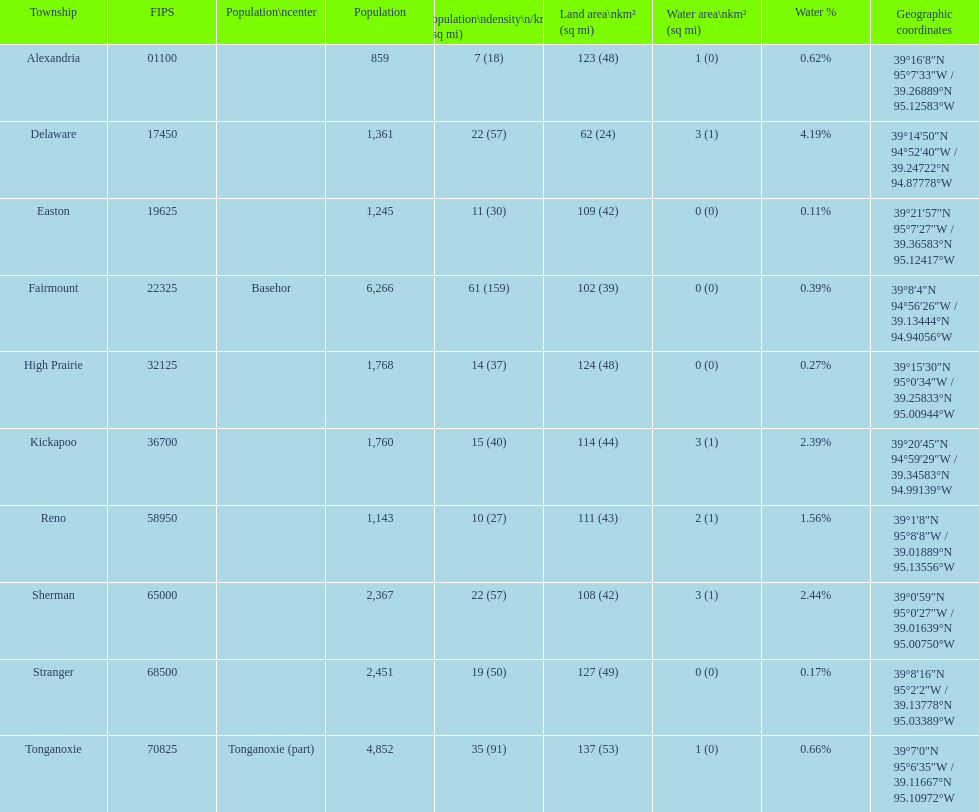What is the variation in population between easton and reno? 102. I'm looking to parse the entire table for insights. Could you assist me with that? {'header': ['Township', 'FIPS', 'Population\\ncenter', 'Population', 'Population\\ndensity\\n/km² (/sq\xa0mi)', 'Land area\\nkm² (sq\xa0mi)', 'Water area\\nkm² (sq\xa0mi)', 'Water\xa0%', 'Geographic coordinates'], 'rows': [['Alexandria', '01100', '', '859', '7 (18)', '123 (48)', '1 (0)', '0.62%', '39°16′8″N 95°7′33″W\ufeff / \ufeff39.26889°N 95.12583°W'], ['Delaware', '17450', '', '1,361', '22 (57)', '62 (24)', '3 (1)', '4.19%', '39°14′50″N 94°52′40″W\ufeff / \ufeff39.24722°N 94.87778°W'], ['Easton', '19625', '', '1,245', '11 (30)', '109 (42)', '0 (0)', '0.11%', '39°21′57″N 95°7′27″W\ufeff / \ufeff39.36583°N 95.12417°W'], ['Fairmount', '22325', 'Basehor', '6,266', '61 (159)', '102 (39)', '0 (0)', '0.39%', '39°8′4″N 94°56′26″W\ufeff / \ufeff39.13444°N 94.94056°W'], ['High Prairie', '32125', '', '1,768', '14 (37)', '124 (48)', '0 (0)', '0.27%', '39°15′30″N 95°0′34″W\ufeff / \ufeff39.25833°N 95.00944°W'], ['Kickapoo', '36700', '', '1,760', '15 (40)', '114 (44)', '3 (1)', '2.39%', '39°20′45″N 94°59′29″W\ufeff / \ufeff39.34583°N 94.99139°W'], ['Reno', '58950', '', '1,143', '10 (27)', '111 (43)', '2 (1)', '1.56%', '39°1′8″N 95°8′8″W\ufeff / \ufeff39.01889°N 95.13556°W'], ['Sherman', '65000', '', '2,367', '22 (57)', '108 (42)', '3 (1)', '2.44%', '39°0′59″N 95°0′27″W\ufeff / \ufeff39.01639°N 95.00750°W'], ['Stranger', '68500', '', '2,451', '19 (50)', '127 (49)', '0 (0)', '0.17%', '39°8′16″N 95°2′2″W\ufeff / \ufeff39.13778°N 95.03389°W'], ['Tonganoxie', '70825', 'Tonganoxie (part)', '4,852', '35 (91)', '137 (53)', '1 (0)', '0.66%', '39°7′0″N 95°6′35″W\ufeff / \ufeff39.11667°N 95.10972°W']]} 